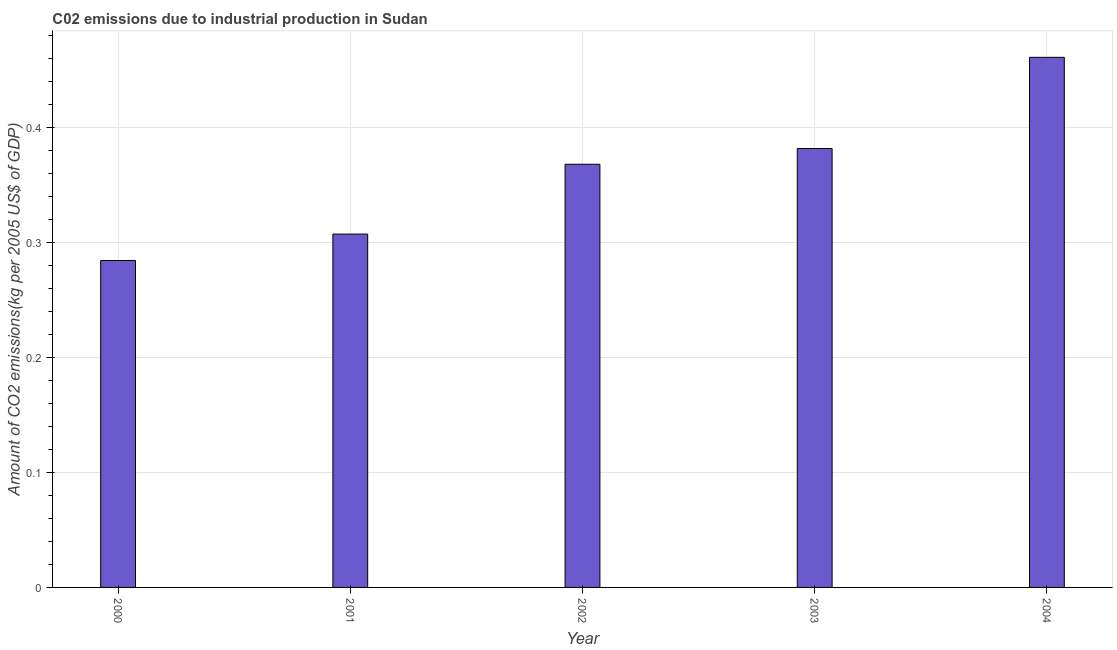Does the graph contain any zero values?
Make the answer very short. No. Does the graph contain grids?
Provide a short and direct response. Yes. What is the title of the graph?
Your response must be concise. C02 emissions due to industrial production in Sudan. What is the label or title of the X-axis?
Keep it short and to the point. Year. What is the label or title of the Y-axis?
Keep it short and to the point. Amount of CO2 emissions(kg per 2005 US$ of GDP). What is the amount of co2 emissions in 2001?
Offer a terse response. 0.31. Across all years, what is the maximum amount of co2 emissions?
Keep it short and to the point. 0.46. Across all years, what is the minimum amount of co2 emissions?
Offer a very short reply. 0.28. In which year was the amount of co2 emissions maximum?
Your response must be concise. 2004. In which year was the amount of co2 emissions minimum?
Give a very brief answer. 2000. What is the sum of the amount of co2 emissions?
Give a very brief answer. 1.8. What is the difference between the amount of co2 emissions in 2000 and 2002?
Your answer should be very brief. -0.08. What is the average amount of co2 emissions per year?
Make the answer very short. 0.36. What is the median amount of co2 emissions?
Ensure brevity in your answer.  0.37. Do a majority of the years between 2002 and 2003 (inclusive) have amount of co2 emissions greater than 0.44 kg per 2005 US$ of GDP?
Provide a succinct answer. No. What is the ratio of the amount of co2 emissions in 2001 to that in 2002?
Keep it short and to the point. 0.83. Is the difference between the amount of co2 emissions in 2000 and 2003 greater than the difference between any two years?
Give a very brief answer. No. What is the difference between the highest and the second highest amount of co2 emissions?
Provide a short and direct response. 0.08. What is the difference between the highest and the lowest amount of co2 emissions?
Offer a terse response. 0.18. How many bars are there?
Your answer should be very brief. 5. Are all the bars in the graph horizontal?
Give a very brief answer. No. How many years are there in the graph?
Keep it short and to the point. 5. What is the difference between two consecutive major ticks on the Y-axis?
Keep it short and to the point. 0.1. Are the values on the major ticks of Y-axis written in scientific E-notation?
Offer a terse response. No. What is the Amount of CO2 emissions(kg per 2005 US$ of GDP) in 2000?
Make the answer very short. 0.28. What is the Amount of CO2 emissions(kg per 2005 US$ of GDP) in 2001?
Provide a short and direct response. 0.31. What is the Amount of CO2 emissions(kg per 2005 US$ of GDP) of 2002?
Ensure brevity in your answer.  0.37. What is the Amount of CO2 emissions(kg per 2005 US$ of GDP) of 2003?
Your response must be concise. 0.38. What is the Amount of CO2 emissions(kg per 2005 US$ of GDP) in 2004?
Provide a succinct answer. 0.46. What is the difference between the Amount of CO2 emissions(kg per 2005 US$ of GDP) in 2000 and 2001?
Provide a short and direct response. -0.02. What is the difference between the Amount of CO2 emissions(kg per 2005 US$ of GDP) in 2000 and 2002?
Keep it short and to the point. -0.08. What is the difference between the Amount of CO2 emissions(kg per 2005 US$ of GDP) in 2000 and 2003?
Offer a terse response. -0.1. What is the difference between the Amount of CO2 emissions(kg per 2005 US$ of GDP) in 2000 and 2004?
Make the answer very short. -0.18. What is the difference between the Amount of CO2 emissions(kg per 2005 US$ of GDP) in 2001 and 2002?
Keep it short and to the point. -0.06. What is the difference between the Amount of CO2 emissions(kg per 2005 US$ of GDP) in 2001 and 2003?
Provide a succinct answer. -0.07. What is the difference between the Amount of CO2 emissions(kg per 2005 US$ of GDP) in 2001 and 2004?
Your answer should be compact. -0.15. What is the difference between the Amount of CO2 emissions(kg per 2005 US$ of GDP) in 2002 and 2003?
Offer a terse response. -0.01. What is the difference between the Amount of CO2 emissions(kg per 2005 US$ of GDP) in 2002 and 2004?
Your response must be concise. -0.09. What is the difference between the Amount of CO2 emissions(kg per 2005 US$ of GDP) in 2003 and 2004?
Give a very brief answer. -0.08. What is the ratio of the Amount of CO2 emissions(kg per 2005 US$ of GDP) in 2000 to that in 2001?
Provide a succinct answer. 0.93. What is the ratio of the Amount of CO2 emissions(kg per 2005 US$ of GDP) in 2000 to that in 2002?
Ensure brevity in your answer.  0.77. What is the ratio of the Amount of CO2 emissions(kg per 2005 US$ of GDP) in 2000 to that in 2003?
Offer a terse response. 0.74. What is the ratio of the Amount of CO2 emissions(kg per 2005 US$ of GDP) in 2000 to that in 2004?
Your response must be concise. 0.62. What is the ratio of the Amount of CO2 emissions(kg per 2005 US$ of GDP) in 2001 to that in 2002?
Provide a succinct answer. 0.83. What is the ratio of the Amount of CO2 emissions(kg per 2005 US$ of GDP) in 2001 to that in 2003?
Make the answer very short. 0.81. What is the ratio of the Amount of CO2 emissions(kg per 2005 US$ of GDP) in 2001 to that in 2004?
Your answer should be compact. 0.67. What is the ratio of the Amount of CO2 emissions(kg per 2005 US$ of GDP) in 2002 to that in 2004?
Your answer should be very brief. 0.8. What is the ratio of the Amount of CO2 emissions(kg per 2005 US$ of GDP) in 2003 to that in 2004?
Provide a short and direct response. 0.83. 